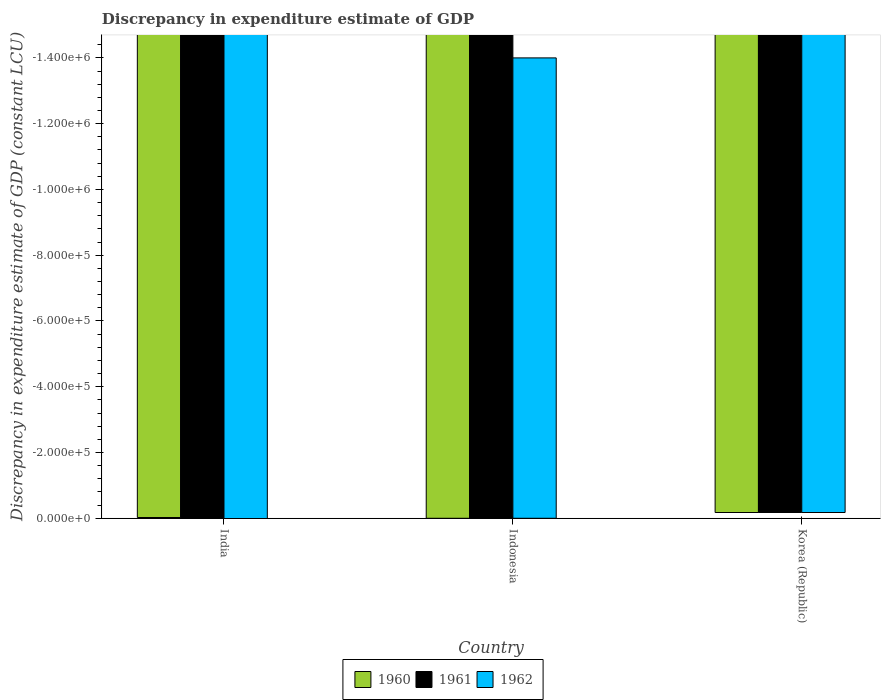How many bars are there on the 1st tick from the left?
Make the answer very short. 0. How many bars are there on the 1st tick from the right?
Ensure brevity in your answer.  0. Across all countries, what is the minimum discrepancy in expenditure estimate of GDP in 1961?
Provide a succinct answer. 0. What is the total discrepancy in expenditure estimate of GDP in 1960 in the graph?
Ensure brevity in your answer.  0. What is the difference between the discrepancy in expenditure estimate of GDP in 1962 in India and the discrepancy in expenditure estimate of GDP in 1960 in Indonesia?
Ensure brevity in your answer.  0. What is the average discrepancy in expenditure estimate of GDP in 1961 per country?
Your answer should be compact. 0. How many bars are there?
Keep it short and to the point. 0. Does the graph contain grids?
Keep it short and to the point. No. Where does the legend appear in the graph?
Your answer should be very brief. Bottom center. How are the legend labels stacked?
Provide a succinct answer. Horizontal. What is the title of the graph?
Provide a short and direct response. Discrepancy in expenditure estimate of GDP. Does "2014" appear as one of the legend labels in the graph?
Offer a very short reply. No. What is the label or title of the X-axis?
Your answer should be very brief. Country. What is the label or title of the Y-axis?
Keep it short and to the point. Discrepancy in expenditure estimate of GDP (constant LCU). What is the Discrepancy in expenditure estimate of GDP (constant LCU) in 1962 in India?
Your answer should be compact. 0. What is the Discrepancy in expenditure estimate of GDP (constant LCU) in 1960 in Indonesia?
Your answer should be very brief. 0. What is the Discrepancy in expenditure estimate of GDP (constant LCU) of 1961 in Indonesia?
Offer a terse response. 0. What is the Discrepancy in expenditure estimate of GDP (constant LCU) in 1962 in Korea (Republic)?
Keep it short and to the point. 0. What is the total Discrepancy in expenditure estimate of GDP (constant LCU) in 1960 in the graph?
Your response must be concise. 0. What is the average Discrepancy in expenditure estimate of GDP (constant LCU) in 1960 per country?
Ensure brevity in your answer.  0. 